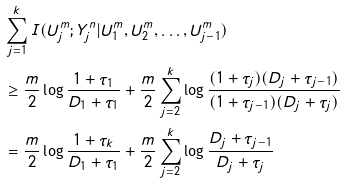<formula> <loc_0><loc_0><loc_500><loc_500>& \sum _ { j = 1 } ^ { k } I ( U ^ { m } _ { j } ; Y ^ { n } _ { j } | U ^ { m } _ { 1 } , U ^ { m } _ { 2 } , \dots , U ^ { m } _ { j - 1 } ) \\ & \geq \frac { m } { 2 } \log \frac { 1 + \tau _ { 1 } } { D _ { 1 } + \tau _ { 1 } } + \frac { m } { 2 } \sum _ { j = 2 } ^ { k } \log \frac { ( 1 + \tau _ { j } ) ( D _ { j } + \tau _ { j - 1 } ) } { ( 1 + \tau _ { j - 1 } ) ( D _ { j } + \tau _ { j } ) } \\ & = \frac { m } { 2 } \log \frac { 1 + \tau _ { k } } { D _ { 1 } + \tau _ { 1 } } + \frac { m } { 2 } \sum _ { j = 2 } ^ { k } \log \frac { D _ { j } + \tau _ { j - 1 } } { D _ { j } + \tau _ { j } }</formula> 